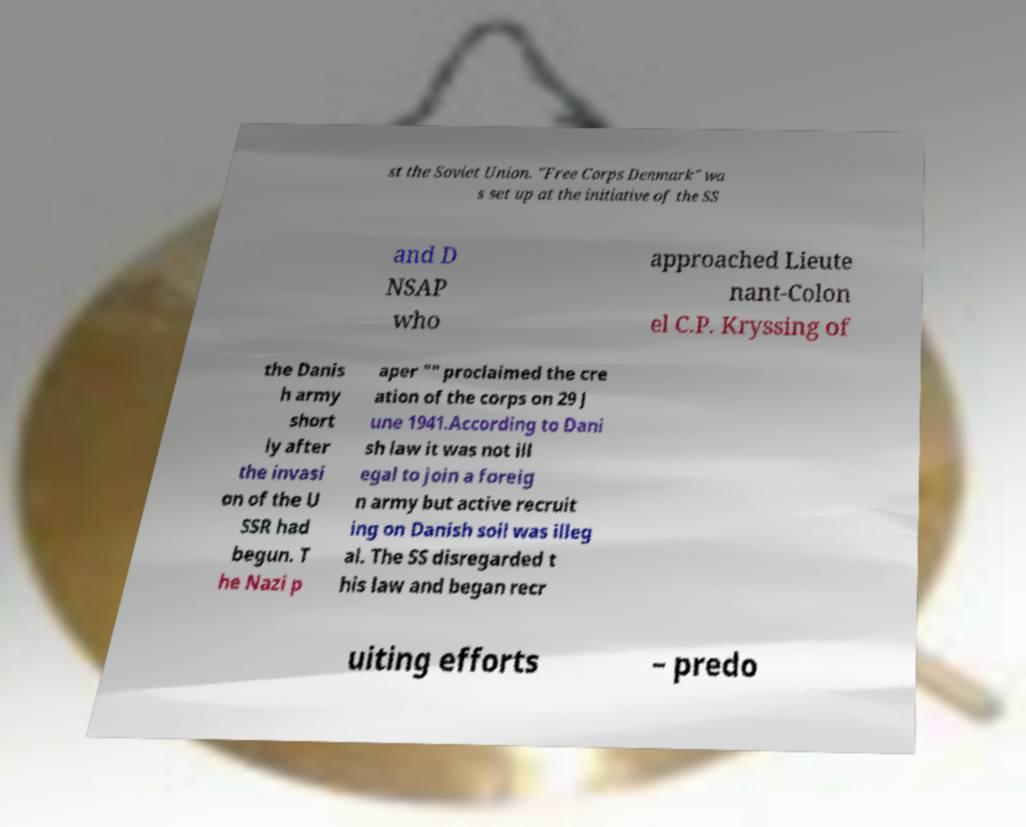Could you assist in decoding the text presented in this image and type it out clearly? st the Soviet Union. "Free Corps Denmark" wa s set up at the initiative of the SS and D NSAP who approached Lieute nant-Colon el C.P. Kryssing of the Danis h army short ly after the invasi on of the U SSR had begun. T he Nazi p aper "" proclaimed the cre ation of the corps on 29 J une 1941.According to Dani sh law it was not ill egal to join a foreig n army but active recruit ing on Danish soil was illeg al. The SS disregarded t his law and began recr uiting efforts – predo 